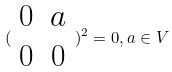<formula> <loc_0><loc_0><loc_500><loc_500>( \begin{array} { c c } 0 & a \\ 0 & 0 \end{array} ) ^ { 2 } = 0 , a \in V</formula> 